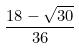Convert formula to latex. <formula><loc_0><loc_0><loc_500><loc_500>\frac { 1 8 - \sqrt { 3 0 } } { 3 6 }</formula> 